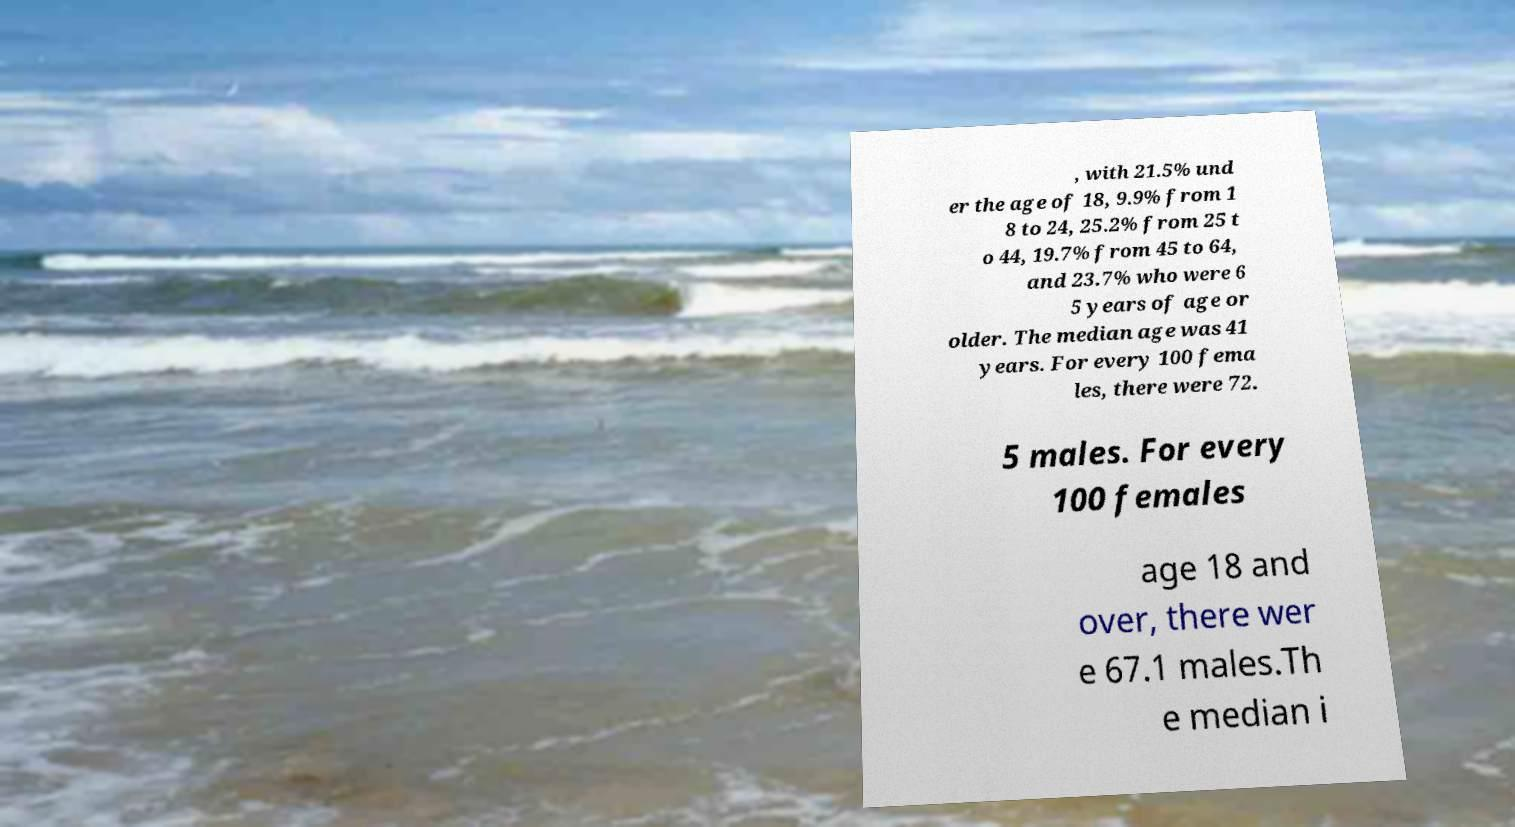For documentation purposes, I need the text within this image transcribed. Could you provide that? , with 21.5% und er the age of 18, 9.9% from 1 8 to 24, 25.2% from 25 t o 44, 19.7% from 45 to 64, and 23.7% who were 6 5 years of age or older. The median age was 41 years. For every 100 fema les, there were 72. 5 males. For every 100 females age 18 and over, there wer e 67.1 males.Th e median i 